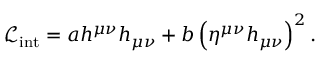<formula> <loc_0><loc_0><loc_500><loc_500>{ \mathcal { L } } _ { i n t } = a h ^ { \mu \nu } h _ { \mu \nu } + b \left ( \eta ^ { \mu \nu } h _ { \mu \nu } \right ) ^ { 2 } .</formula> 